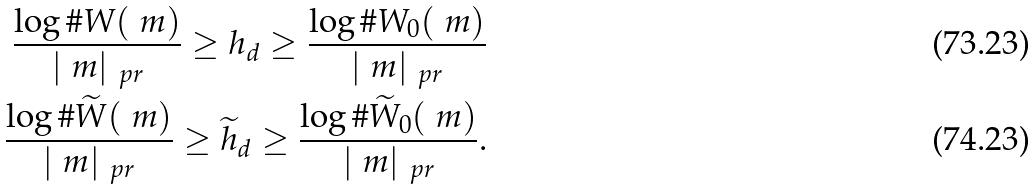<formula> <loc_0><loc_0><loc_500><loc_500>\frac { \log \# W ( \ m ) } { | \ m | _ { \ p r } } \geq h _ { d } \geq \frac { \log \# W _ { 0 } ( \ m ) } { | \ m | _ { \ p r } } \\ \frac { \log \# \widetilde { W } ( \ m ) } { | \ m | _ { \ p r } } \geq \widetilde { h } _ { d } \geq \frac { \log \# \widetilde { W } _ { 0 } ( \ m ) } { | \ m | _ { \ p r } } .</formula> 